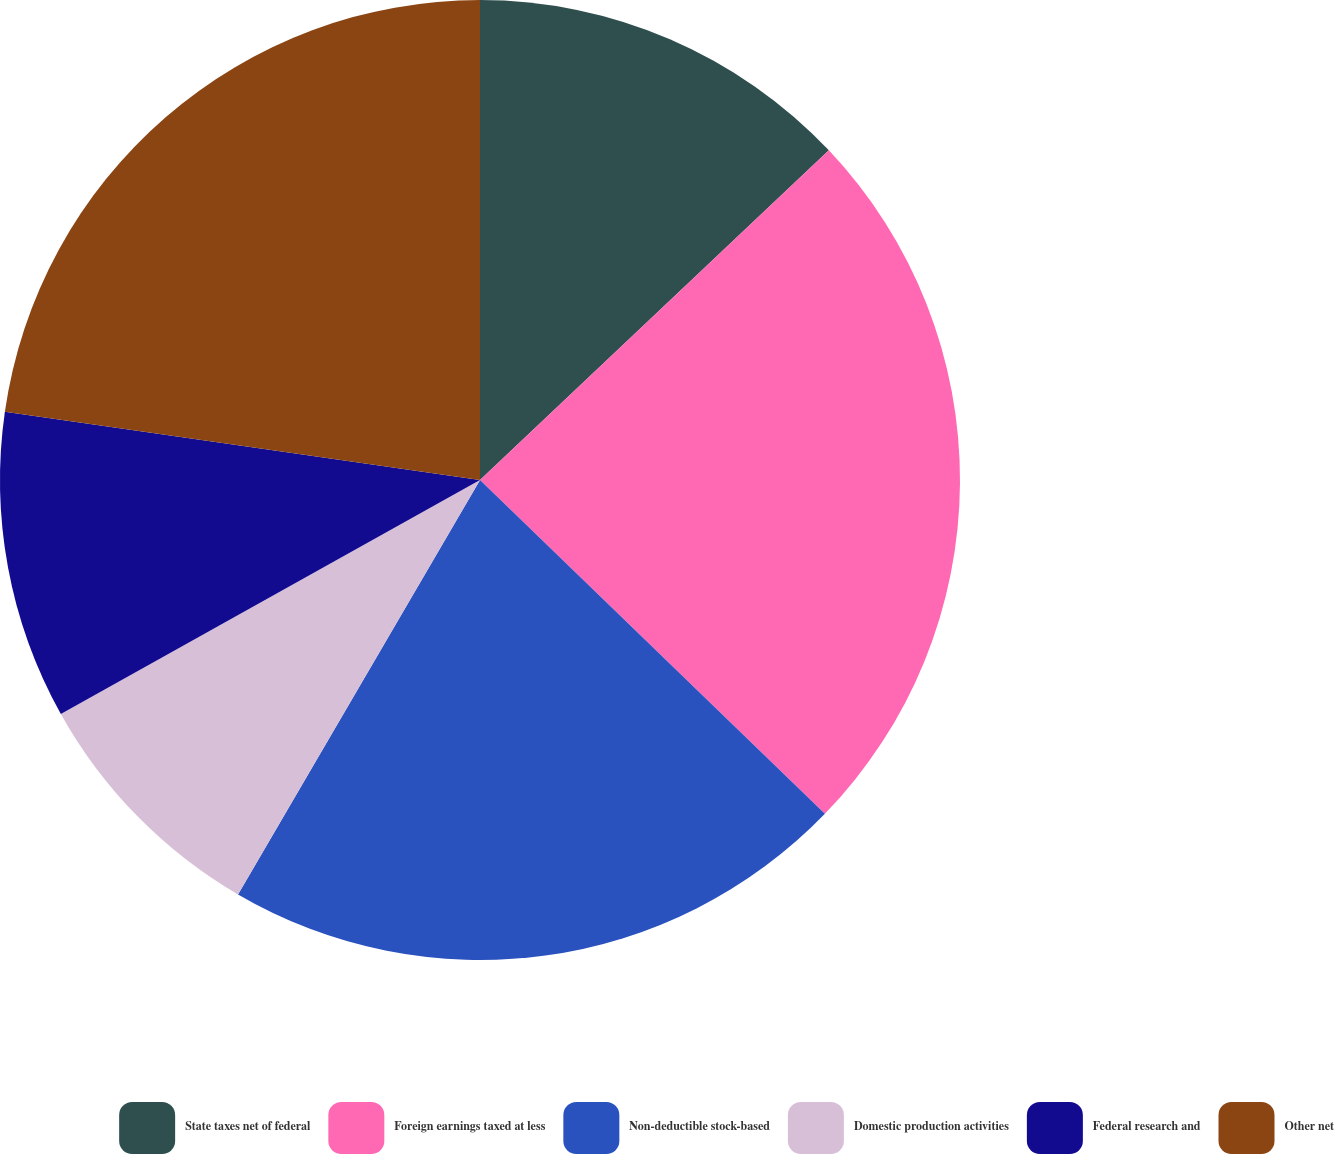Convert chart to OTSL. <chart><loc_0><loc_0><loc_500><loc_500><pie_chart><fcel>State taxes net of federal<fcel>Foreign earnings taxed at less<fcel>Non-deductible stock-based<fcel>Domestic production activities<fcel>Federal research and<fcel>Other net<nl><fcel>12.95%<fcel>24.29%<fcel>21.17%<fcel>8.49%<fcel>10.37%<fcel>22.73%<nl></chart> 